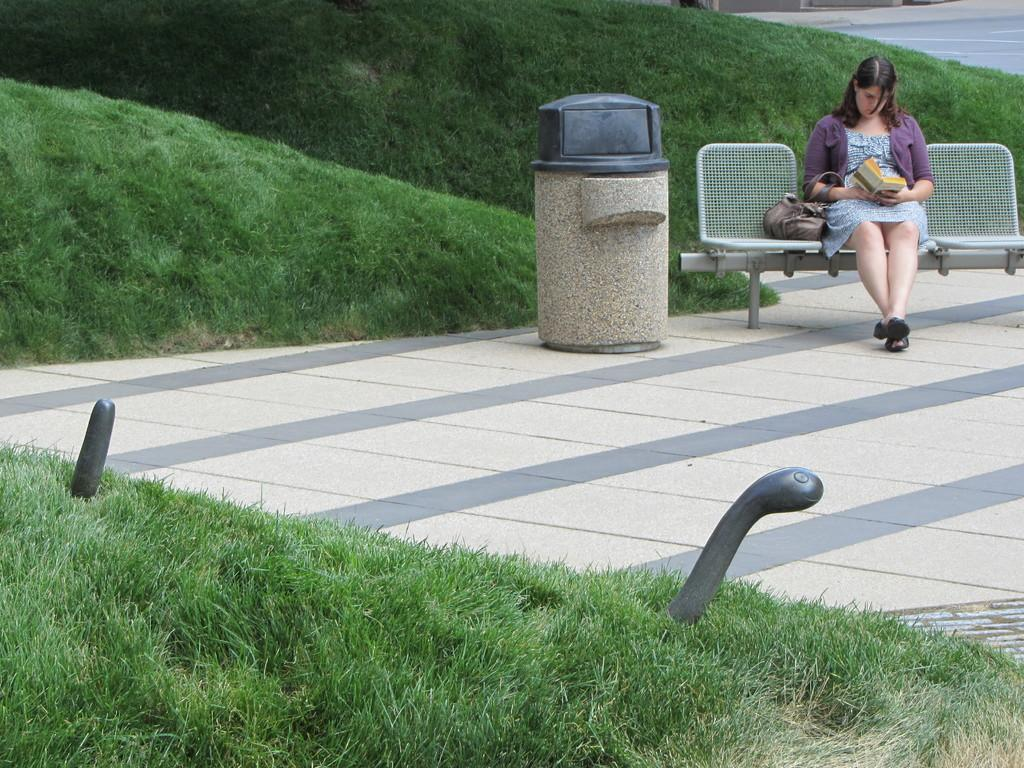What type of vegetation can be seen in the image? There is grass in the image. What is the woman in the image doing? The woman is seated on a chair and reading a book. Can you describe any additional objects in the image? There is a bag in the image. What type of space exploration is the woman participating in while reading the book in the image? There is no indication of space exploration in the image; the woman is simply reading a book while seated on a chair. Can you describe any blood or injuries visible in the image? There is no blood or injuries visible in the image; it features a woman reading a book and grass. 